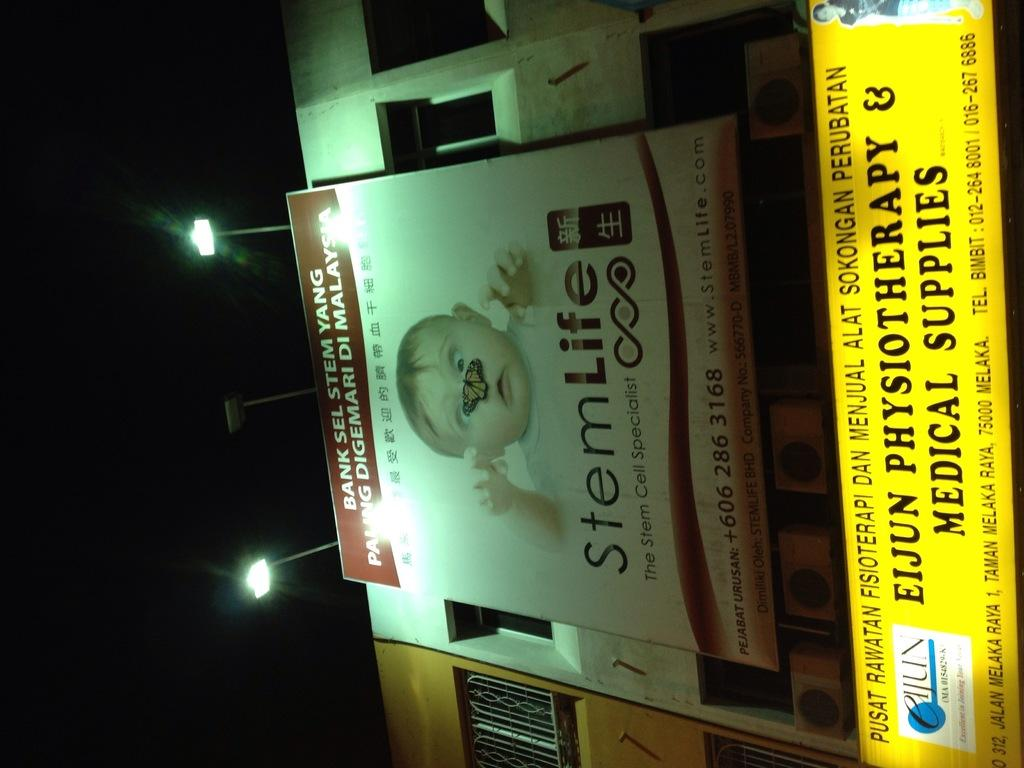<image>
Give a short and clear explanation of the subsequent image. A billboard in Malaysia advertises a stem cell service. 